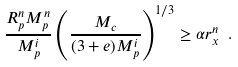Convert formula to latex. <formula><loc_0><loc_0><loc_500><loc_500>\frac { R _ { p } ^ { n } M _ { p } ^ { n } } { M _ { p } ^ { i } } \left ( \frac { M _ { c } } { ( 3 + e ) M _ { p } ^ { i } } \right ) ^ { 1 / 3 } \geq \alpha r _ { x } ^ { n } \ .</formula> 